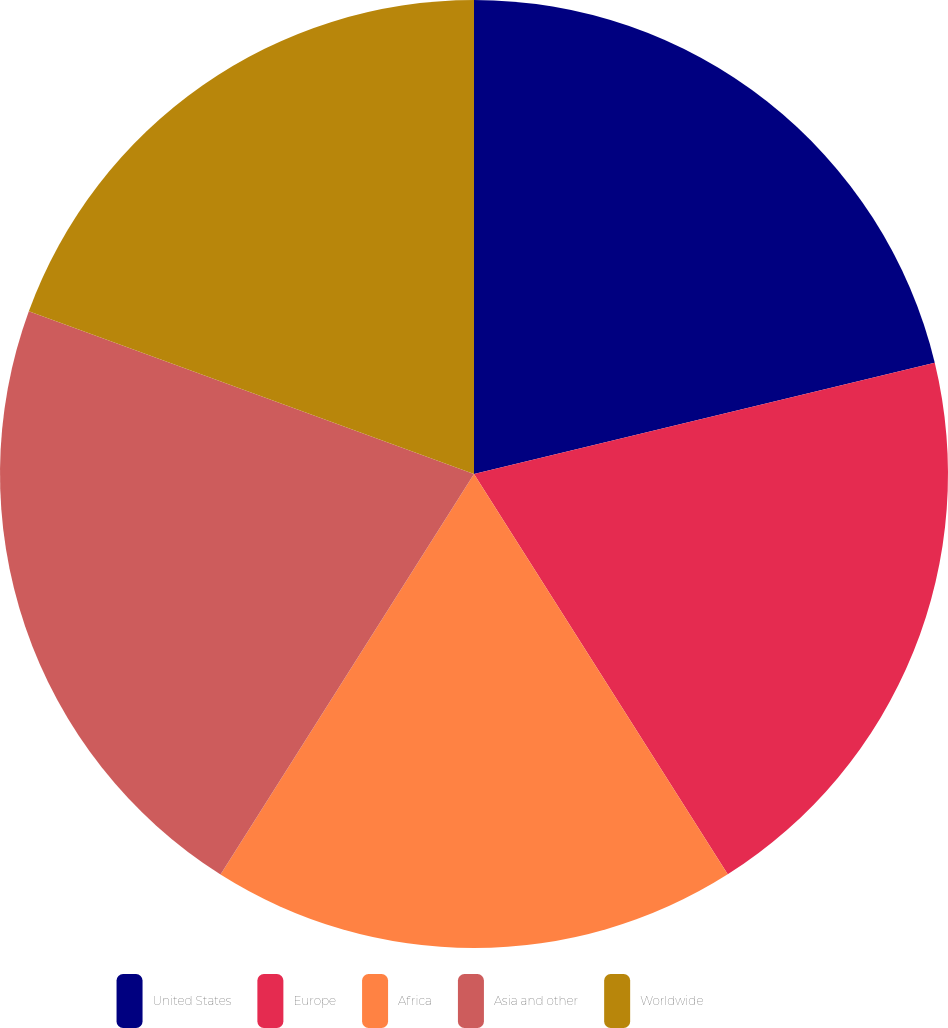<chart> <loc_0><loc_0><loc_500><loc_500><pie_chart><fcel>United States<fcel>Europe<fcel>Africa<fcel>Asia and other<fcel>Worldwide<nl><fcel>21.23%<fcel>19.78%<fcel>17.97%<fcel>21.6%<fcel>19.42%<nl></chart> 